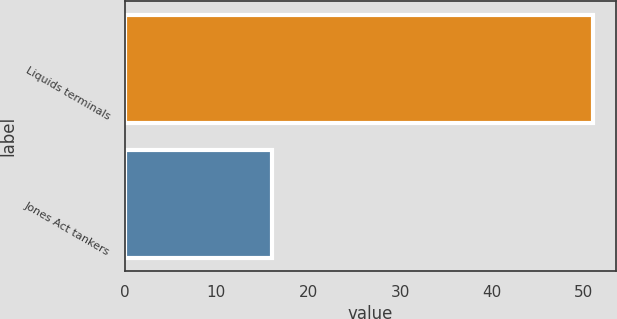Convert chart to OTSL. <chart><loc_0><loc_0><loc_500><loc_500><bar_chart><fcel>Liquids terminals<fcel>Jones Act tankers<nl><fcel>51<fcel>16<nl></chart> 